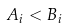<formula> <loc_0><loc_0><loc_500><loc_500>A _ { i } < B _ { i }</formula> 